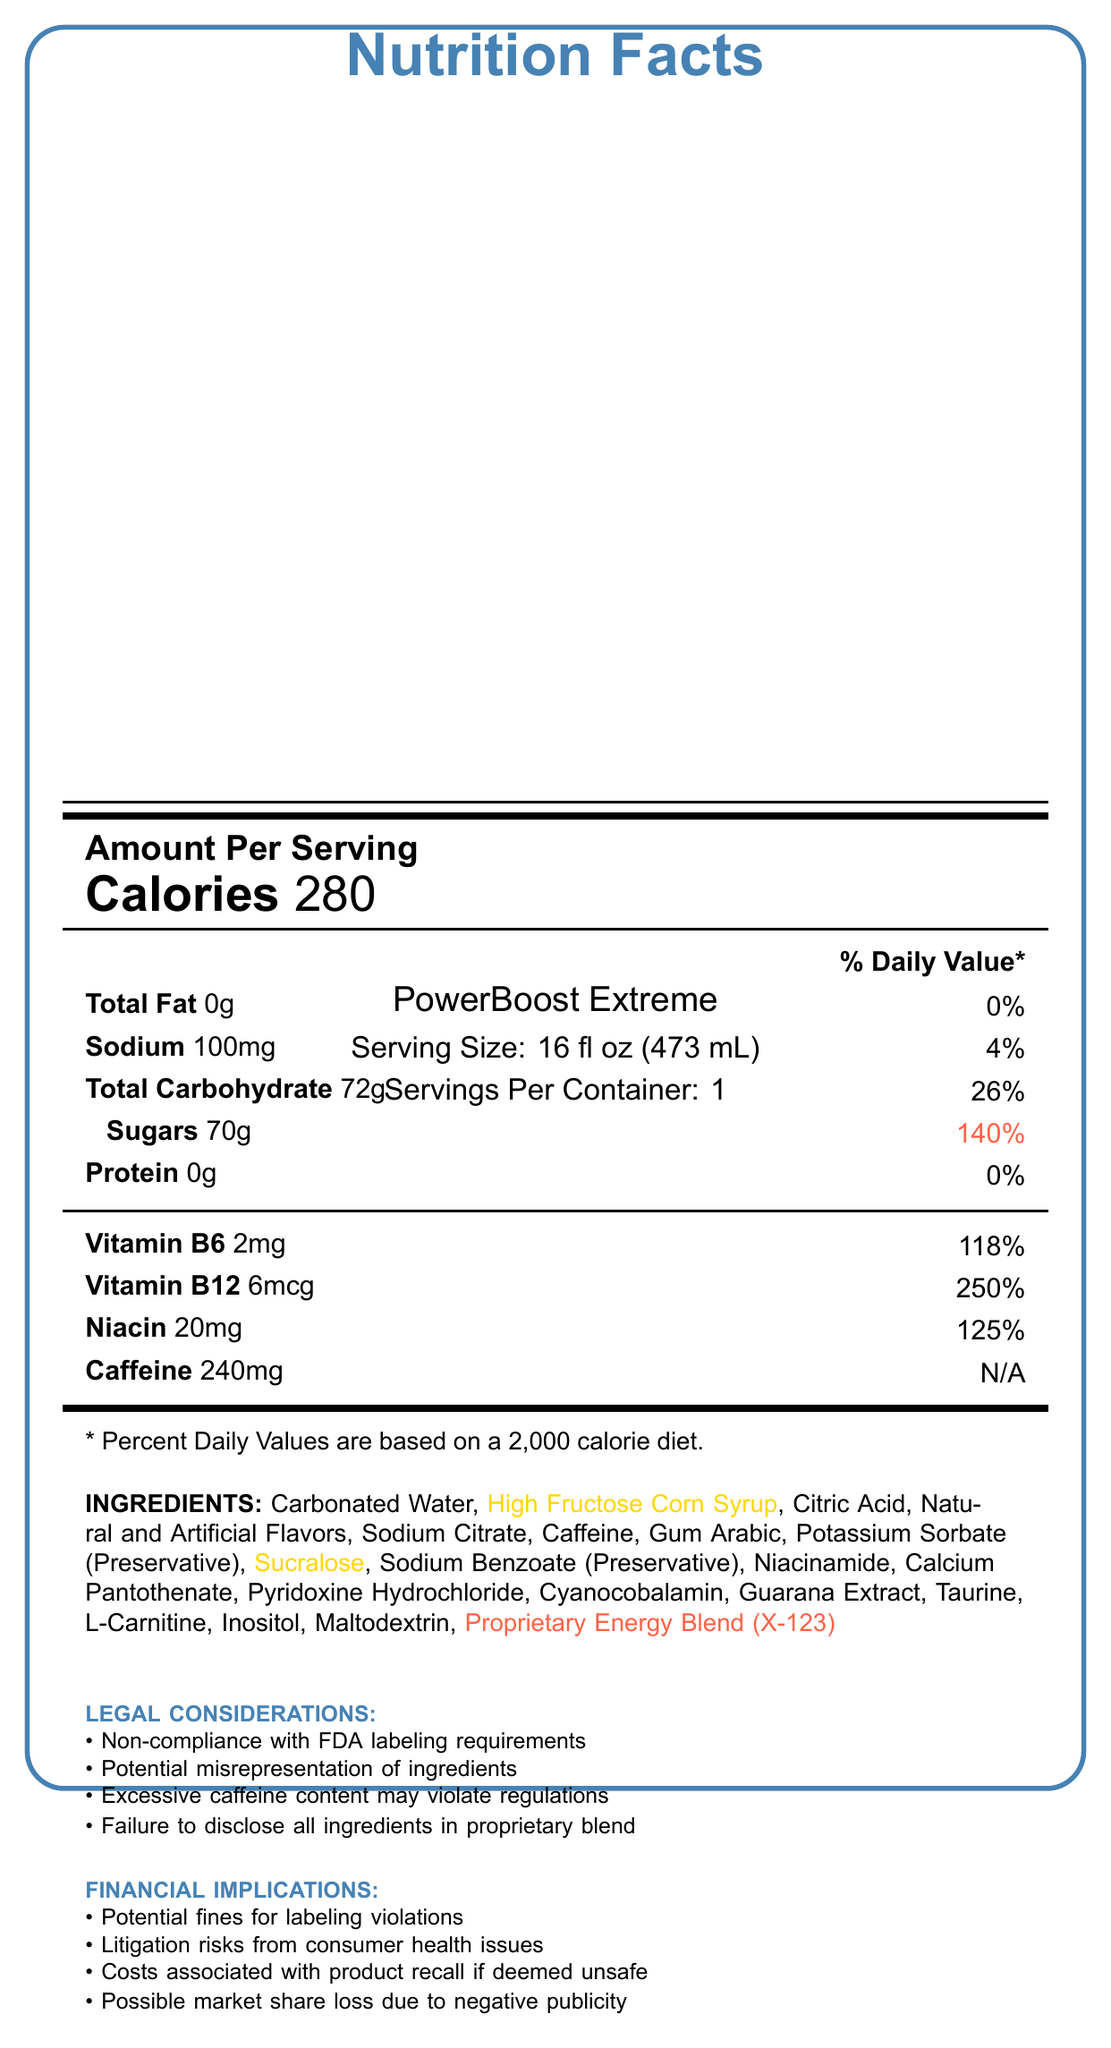what is the serving size of PowerBoost Extreme? The serving size is listed at the top of the Nutrition Facts Label under the product name "PowerBoost Extreme."
Answer: 16 fl oz (473 mL) how many calories are there per serving of PowerBoost Extreme? The number of calories per serving is prominently displayed under the section "Amount Per Serving."
Answer: 280 what percentage of the daily value of sugar does one serving of PowerBoost Extreme contain? This information is listed next to the "Sugars" entry in the Nutrition Facts Label.
Answer: 140% how much caffeine does one serving of PowerBoost Extreme contain? The amount of caffeine is listed under the "Caffeine" section of the Nutrition Facts.
Answer: 240mg what is the main concern listed for the ingredient "Proprietary Energy Blend (X-123)"? The concern regarding this ingredient is listed in the suspicious ingredients section.
Answer: Undisclosed formula, potential for harmful or illegal substances which ingredient is highlighted as having potential long-term health effects due to being an artificial sweetener? In the ingredients list, Sucralose is highlighted as having potential long-term health effects because it is an artificial sweetener.
Answer: Sucralose which of the following is NOT a potential financial implication listed in the document? A. Litigation risks from consumer health issues B. Increased production costs C. Potential fines for labeling violations D. Possible market share loss due to negative publicity Increased production costs are not mentioned in the list of financial implications.
Answer: B which vitamins in PowerBoost Extreme have an amount that significantly exceeds 100% of the daily value? A. Vitamin B6 B. Vitamin B12 C. Niacin D. All of the above Vitamin B6 (118%), Vitamin B12 (250%), and Niacin (125%) all exceed 100% of the daily value.
Answer: D does the document list any potential violations of FDA regulations? Under the "Legal Considerations" section, potential violations such as non-compliance with FDA labeling requirements and excessive caffeine content are mentioned.
Answer: Yes summarize the key points of the Nutrition Facts Label for PowerBoost Extreme. The key points of the label are its high caloric and sugar content, the concerning ingredients, legal implications, and potential financial risks.
Answer: The Nutrition Facts Label for PowerBoost Extreme provides detailed nutritional information, including 280 calories per serving and high sugar content (140% of daily value). It also lists ingredients, with specific concerns highlighted for high fructose corn syrup, sucralose, and a proprietary energy blend. There are legal considerations and financial implications due to potential FDA regulation non-compliance and health risks. what exact components make up the proprietary blend in PowerBoost Extreme? The document does not provide details on the specific components of the proprietary energy blend, only noting that it is suspicious due to its undisclosed formula.
Answer: Not enough information 